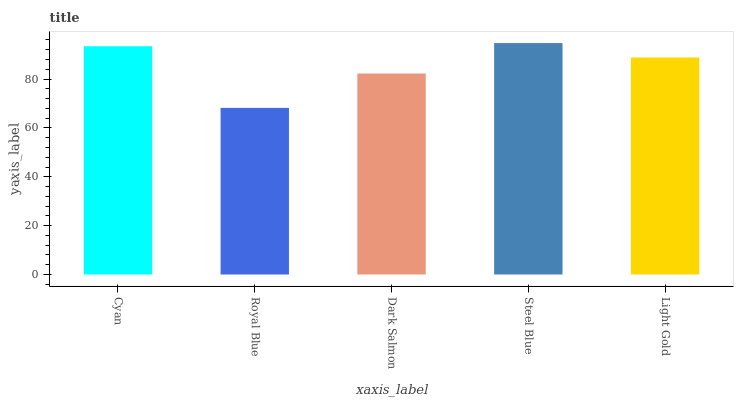Is Dark Salmon the minimum?
Answer yes or no. No. Is Dark Salmon the maximum?
Answer yes or no. No. Is Dark Salmon greater than Royal Blue?
Answer yes or no. Yes. Is Royal Blue less than Dark Salmon?
Answer yes or no. Yes. Is Royal Blue greater than Dark Salmon?
Answer yes or no. No. Is Dark Salmon less than Royal Blue?
Answer yes or no. No. Is Light Gold the high median?
Answer yes or no. Yes. Is Light Gold the low median?
Answer yes or no. Yes. Is Steel Blue the high median?
Answer yes or no. No. Is Dark Salmon the low median?
Answer yes or no. No. 